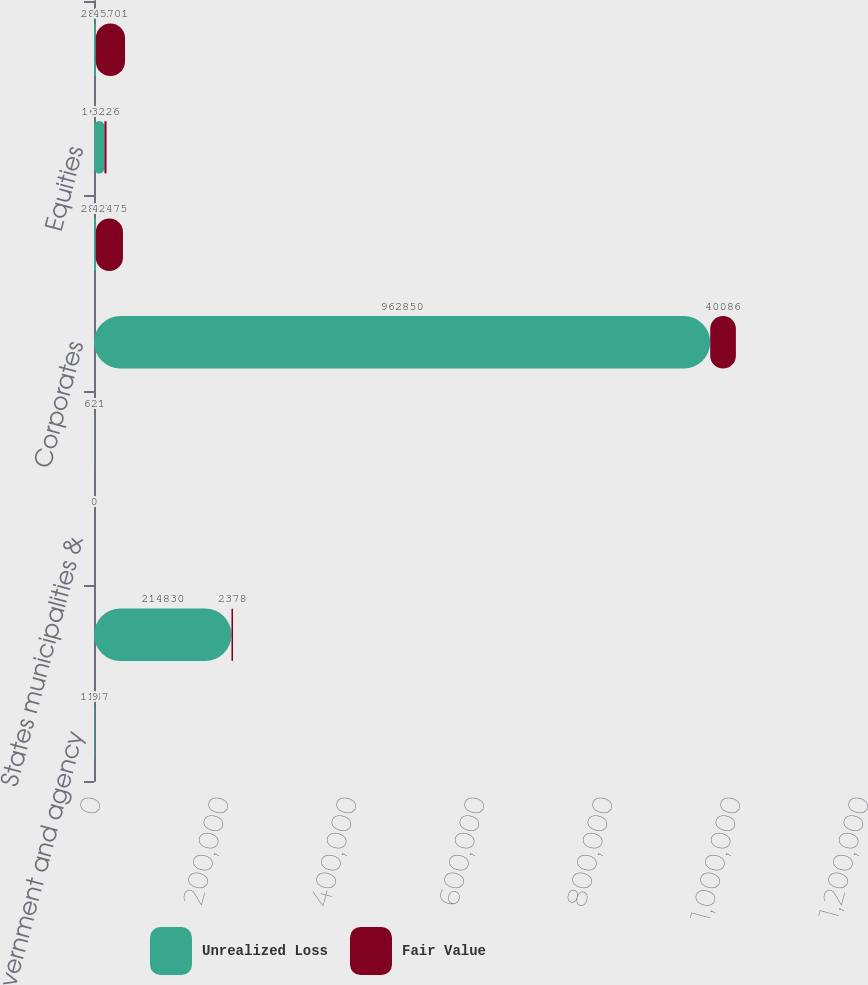<chart> <loc_0><loc_0><loc_500><loc_500><stacked_bar_chart><ecel><fcel>US Government and agency<fcel>Government-sponsored<fcel>States municipalities &<fcel>Foreign governments<fcel>Corporates<fcel>Total fixed maturities<fcel>Equities<fcel>Total<nl><fcel>Unrealized Loss<fcel>1137<fcel>214830<fcel>0<fcel>691<fcel>962850<fcel>2802<fcel>16308<fcel>2802<nl><fcel>Fair Value<fcel>9<fcel>2378<fcel>0<fcel>2<fcel>40086<fcel>42475<fcel>3226<fcel>45701<nl></chart> 